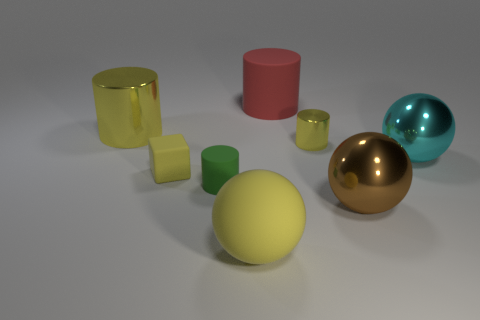Subtract 1 cylinders. How many cylinders are left? 3 Add 2 red cylinders. How many objects exist? 10 Subtract all spheres. How many objects are left? 5 Subtract all green things. Subtract all large cyan spheres. How many objects are left? 6 Add 2 tiny green objects. How many tiny green objects are left? 3 Add 5 big brown metallic spheres. How many big brown metallic spheres exist? 6 Subtract 2 yellow cylinders. How many objects are left? 6 